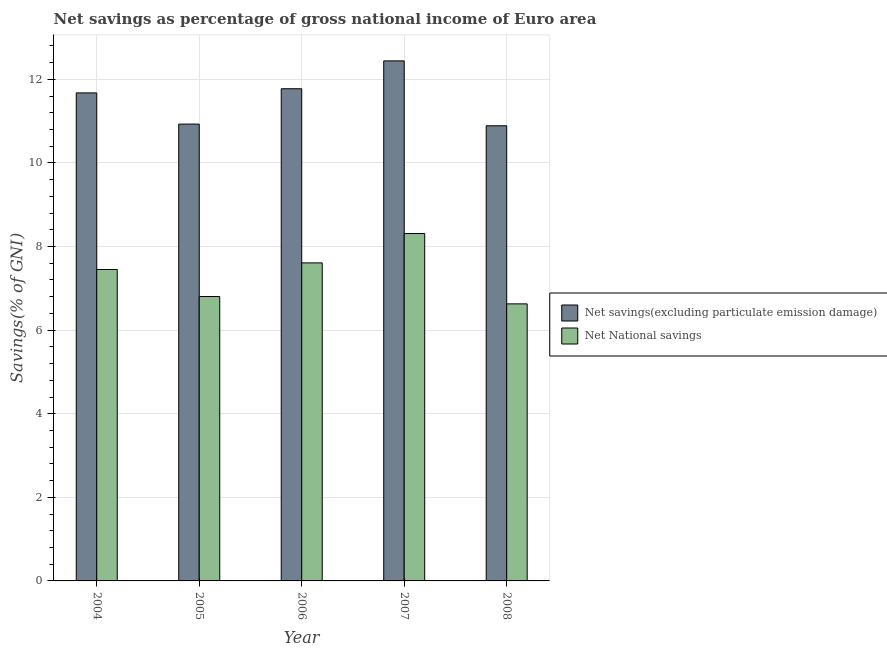How many different coloured bars are there?
Your response must be concise. 2. Are the number of bars per tick equal to the number of legend labels?
Provide a succinct answer. Yes. Are the number of bars on each tick of the X-axis equal?
Provide a short and direct response. Yes. What is the label of the 3rd group of bars from the left?
Your answer should be very brief. 2006. What is the net national savings in 2008?
Ensure brevity in your answer.  6.63. Across all years, what is the maximum net savings(excluding particulate emission damage)?
Provide a succinct answer. 12.44. Across all years, what is the minimum net savings(excluding particulate emission damage)?
Offer a terse response. 10.89. In which year was the net savings(excluding particulate emission damage) maximum?
Provide a succinct answer. 2007. In which year was the net savings(excluding particulate emission damage) minimum?
Make the answer very short. 2008. What is the total net national savings in the graph?
Keep it short and to the point. 36.8. What is the difference between the net national savings in 2005 and that in 2007?
Offer a terse response. -1.51. What is the difference between the net savings(excluding particulate emission damage) in 2007 and the net national savings in 2004?
Your response must be concise. 0.77. What is the average net savings(excluding particulate emission damage) per year?
Your answer should be very brief. 11.54. What is the ratio of the net national savings in 2007 to that in 2008?
Provide a short and direct response. 1.25. What is the difference between the highest and the second highest net savings(excluding particulate emission damage)?
Your answer should be very brief. 0.67. What is the difference between the highest and the lowest net national savings?
Provide a short and direct response. 1.68. In how many years, is the net national savings greater than the average net national savings taken over all years?
Provide a succinct answer. 3. Is the sum of the net savings(excluding particulate emission damage) in 2005 and 2006 greater than the maximum net national savings across all years?
Make the answer very short. Yes. What does the 2nd bar from the left in 2004 represents?
Ensure brevity in your answer.  Net National savings. What does the 2nd bar from the right in 2008 represents?
Your answer should be very brief. Net savings(excluding particulate emission damage). How many bars are there?
Offer a very short reply. 10. What is the difference between two consecutive major ticks on the Y-axis?
Your answer should be compact. 2. Are the values on the major ticks of Y-axis written in scientific E-notation?
Your answer should be very brief. No. Does the graph contain any zero values?
Provide a short and direct response. No. Does the graph contain grids?
Offer a terse response. Yes. Where does the legend appear in the graph?
Make the answer very short. Center right. What is the title of the graph?
Ensure brevity in your answer.  Net savings as percentage of gross national income of Euro area. What is the label or title of the X-axis?
Provide a succinct answer. Year. What is the label or title of the Y-axis?
Provide a succinct answer. Savings(% of GNI). What is the Savings(% of GNI) of Net savings(excluding particulate emission damage) in 2004?
Ensure brevity in your answer.  11.68. What is the Savings(% of GNI) of Net National savings in 2004?
Make the answer very short. 7.45. What is the Savings(% of GNI) in Net savings(excluding particulate emission damage) in 2005?
Give a very brief answer. 10.93. What is the Savings(% of GNI) in Net National savings in 2005?
Offer a very short reply. 6.8. What is the Savings(% of GNI) of Net savings(excluding particulate emission damage) in 2006?
Your answer should be compact. 11.77. What is the Savings(% of GNI) of Net National savings in 2006?
Provide a succinct answer. 7.61. What is the Savings(% of GNI) in Net savings(excluding particulate emission damage) in 2007?
Make the answer very short. 12.44. What is the Savings(% of GNI) in Net National savings in 2007?
Your answer should be compact. 8.31. What is the Savings(% of GNI) in Net savings(excluding particulate emission damage) in 2008?
Make the answer very short. 10.89. What is the Savings(% of GNI) of Net National savings in 2008?
Provide a succinct answer. 6.63. Across all years, what is the maximum Savings(% of GNI) of Net savings(excluding particulate emission damage)?
Your answer should be compact. 12.44. Across all years, what is the maximum Savings(% of GNI) of Net National savings?
Provide a short and direct response. 8.31. Across all years, what is the minimum Savings(% of GNI) in Net savings(excluding particulate emission damage)?
Ensure brevity in your answer.  10.89. Across all years, what is the minimum Savings(% of GNI) in Net National savings?
Provide a short and direct response. 6.63. What is the total Savings(% of GNI) in Net savings(excluding particulate emission damage) in the graph?
Provide a short and direct response. 57.71. What is the total Savings(% of GNI) in Net National savings in the graph?
Provide a short and direct response. 36.8. What is the difference between the Savings(% of GNI) in Net savings(excluding particulate emission damage) in 2004 and that in 2005?
Provide a succinct answer. 0.75. What is the difference between the Savings(% of GNI) of Net National savings in 2004 and that in 2005?
Make the answer very short. 0.65. What is the difference between the Savings(% of GNI) of Net savings(excluding particulate emission damage) in 2004 and that in 2006?
Make the answer very short. -0.1. What is the difference between the Savings(% of GNI) of Net National savings in 2004 and that in 2006?
Keep it short and to the point. -0.16. What is the difference between the Savings(% of GNI) of Net savings(excluding particulate emission damage) in 2004 and that in 2007?
Your answer should be compact. -0.77. What is the difference between the Savings(% of GNI) in Net National savings in 2004 and that in 2007?
Offer a very short reply. -0.86. What is the difference between the Savings(% of GNI) in Net savings(excluding particulate emission damage) in 2004 and that in 2008?
Your answer should be compact. 0.79. What is the difference between the Savings(% of GNI) in Net National savings in 2004 and that in 2008?
Your answer should be compact. 0.82. What is the difference between the Savings(% of GNI) of Net savings(excluding particulate emission damage) in 2005 and that in 2006?
Your answer should be compact. -0.85. What is the difference between the Savings(% of GNI) in Net National savings in 2005 and that in 2006?
Offer a very short reply. -0.8. What is the difference between the Savings(% of GNI) in Net savings(excluding particulate emission damage) in 2005 and that in 2007?
Your response must be concise. -1.51. What is the difference between the Savings(% of GNI) in Net National savings in 2005 and that in 2007?
Your answer should be very brief. -1.51. What is the difference between the Savings(% of GNI) of Net savings(excluding particulate emission damage) in 2005 and that in 2008?
Your answer should be compact. 0.04. What is the difference between the Savings(% of GNI) of Net National savings in 2005 and that in 2008?
Your response must be concise. 0.18. What is the difference between the Savings(% of GNI) in Net National savings in 2006 and that in 2007?
Keep it short and to the point. -0.7. What is the difference between the Savings(% of GNI) of Net savings(excluding particulate emission damage) in 2006 and that in 2008?
Offer a terse response. 0.89. What is the difference between the Savings(% of GNI) of Net National savings in 2006 and that in 2008?
Keep it short and to the point. 0.98. What is the difference between the Savings(% of GNI) in Net savings(excluding particulate emission damage) in 2007 and that in 2008?
Your response must be concise. 1.55. What is the difference between the Savings(% of GNI) of Net National savings in 2007 and that in 2008?
Your answer should be compact. 1.68. What is the difference between the Savings(% of GNI) of Net savings(excluding particulate emission damage) in 2004 and the Savings(% of GNI) of Net National savings in 2005?
Give a very brief answer. 4.87. What is the difference between the Savings(% of GNI) of Net savings(excluding particulate emission damage) in 2004 and the Savings(% of GNI) of Net National savings in 2006?
Give a very brief answer. 4.07. What is the difference between the Savings(% of GNI) in Net savings(excluding particulate emission damage) in 2004 and the Savings(% of GNI) in Net National savings in 2007?
Ensure brevity in your answer.  3.37. What is the difference between the Savings(% of GNI) of Net savings(excluding particulate emission damage) in 2004 and the Savings(% of GNI) of Net National savings in 2008?
Keep it short and to the point. 5.05. What is the difference between the Savings(% of GNI) in Net savings(excluding particulate emission damage) in 2005 and the Savings(% of GNI) in Net National savings in 2006?
Offer a very short reply. 3.32. What is the difference between the Savings(% of GNI) in Net savings(excluding particulate emission damage) in 2005 and the Savings(% of GNI) in Net National savings in 2007?
Give a very brief answer. 2.62. What is the difference between the Savings(% of GNI) of Net savings(excluding particulate emission damage) in 2005 and the Savings(% of GNI) of Net National savings in 2008?
Keep it short and to the point. 4.3. What is the difference between the Savings(% of GNI) in Net savings(excluding particulate emission damage) in 2006 and the Savings(% of GNI) in Net National savings in 2007?
Your answer should be very brief. 3.46. What is the difference between the Savings(% of GNI) of Net savings(excluding particulate emission damage) in 2006 and the Savings(% of GNI) of Net National savings in 2008?
Provide a short and direct response. 5.15. What is the difference between the Savings(% of GNI) of Net savings(excluding particulate emission damage) in 2007 and the Savings(% of GNI) of Net National savings in 2008?
Your answer should be very brief. 5.81. What is the average Savings(% of GNI) in Net savings(excluding particulate emission damage) per year?
Give a very brief answer. 11.54. What is the average Savings(% of GNI) of Net National savings per year?
Keep it short and to the point. 7.36. In the year 2004, what is the difference between the Savings(% of GNI) in Net savings(excluding particulate emission damage) and Savings(% of GNI) in Net National savings?
Offer a terse response. 4.23. In the year 2005, what is the difference between the Savings(% of GNI) of Net savings(excluding particulate emission damage) and Savings(% of GNI) of Net National savings?
Make the answer very short. 4.13. In the year 2006, what is the difference between the Savings(% of GNI) in Net savings(excluding particulate emission damage) and Savings(% of GNI) in Net National savings?
Give a very brief answer. 4.17. In the year 2007, what is the difference between the Savings(% of GNI) of Net savings(excluding particulate emission damage) and Savings(% of GNI) of Net National savings?
Provide a succinct answer. 4.13. In the year 2008, what is the difference between the Savings(% of GNI) of Net savings(excluding particulate emission damage) and Savings(% of GNI) of Net National savings?
Your answer should be compact. 4.26. What is the ratio of the Savings(% of GNI) of Net savings(excluding particulate emission damage) in 2004 to that in 2005?
Your answer should be very brief. 1.07. What is the ratio of the Savings(% of GNI) of Net National savings in 2004 to that in 2005?
Your response must be concise. 1.09. What is the ratio of the Savings(% of GNI) of Net savings(excluding particulate emission damage) in 2004 to that in 2006?
Provide a succinct answer. 0.99. What is the ratio of the Savings(% of GNI) in Net National savings in 2004 to that in 2006?
Your answer should be very brief. 0.98. What is the ratio of the Savings(% of GNI) of Net savings(excluding particulate emission damage) in 2004 to that in 2007?
Make the answer very short. 0.94. What is the ratio of the Savings(% of GNI) in Net National savings in 2004 to that in 2007?
Your response must be concise. 0.9. What is the ratio of the Savings(% of GNI) of Net savings(excluding particulate emission damage) in 2004 to that in 2008?
Your response must be concise. 1.07. What is the ratio of the Savings(% of GNI) in Net National savings in 2004 to that in 2008?
Offer a terse response. 1.12. What is the ratio of the Savings(% of GNI) of Net savings(excluding particulate emission damage) in 2005 to that in 2006?
Ensure brevity in your answer.  0.93. What is the ratio of the Savings(% of GNI) in Net National savings in 2005 to that in 2006?
Provide a succinct answer. 0.89. What is the ratio of the Savings(% of GNI) of Net savings(excluding particulate emission damage) in 2005 to that in 2007?
Your answer should be compact. 0.88. What is the ratio of the Savings(% of GNI) in Net National savings in 2005 to that in 2007?
Offer a very short reply. 0.82. What is the ratio of the Savings(% of GNI) of Net savings(excluding particulate emission damage) in 2005 to that in 2008?
Keep it short and to the point. 1. What is the ratio of the Savings(% of GNI) of Net National savings in 2005 to that in 2008?
Make the answer very short. 1.03. What is the ratio of the Savings(% of GNI) of Net savings(excluding particulate emission damage) in 2006 to that in 2007?
Provide a short and direct response. 0.95. What is the ratio of the Savings(% of GNI) in Net National savings in 2006 to that in 2007?
Provide a short and direct response. 0.92. What is the ratio of the Savings(% of GNI) in Net savings(excluding particulate emission damage) in 2006 to that in 2008?
Your answer should be compact. 1.08. What is the ratio of the Savings(% of GNI) of Net National savings in 2006 to that in 2008?
Your answer should be compact. 1.15. What is the ratio of the Savings(% of GNI) in Net savings(excluding particulate emission damage) in 2007 to that in 2008?
Provide a short and direct response. 1.14. What is the ratio of the Savings(% of GNI) of Net National savings in 2007 to that in 2008?
Make the answer very short. 1.25. What is the difference between the highest and the second highest Savings(% of GNI) of Net National savings?
Provide a short and direct response. 0.7. What is the difference between the highest and the lowest Savings(% of GNI) of Net savings(excluding particulate emission damage)?
Offer a very short reply. 1.55. What is the difference between the highest and the lowest Savings(% of GNI) of Net National savings?
Ensure brevity in your answer.  1.68. 